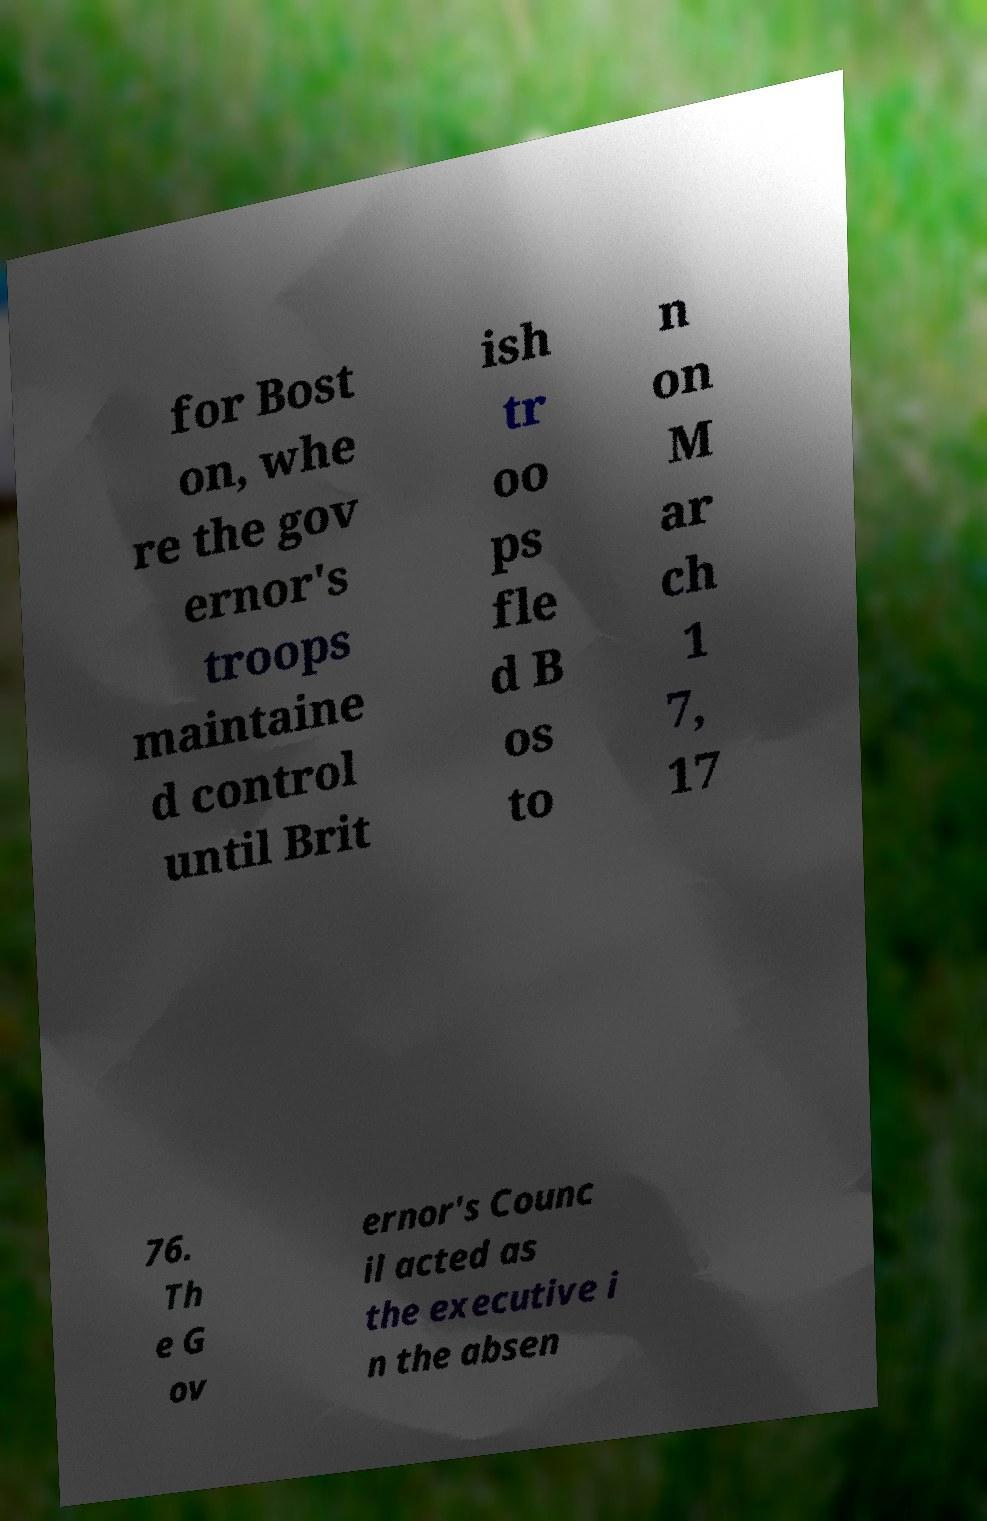I need the written content from this picture converted into text. Can you do that? for Bost on, whe re the gov ernor's troops maintaine d control until Brit ish tr oo ps fle d B os to n on M ar ch 1 7, 17 76. Th e G ov ernor's Counc il acted as the executive i n the absen 